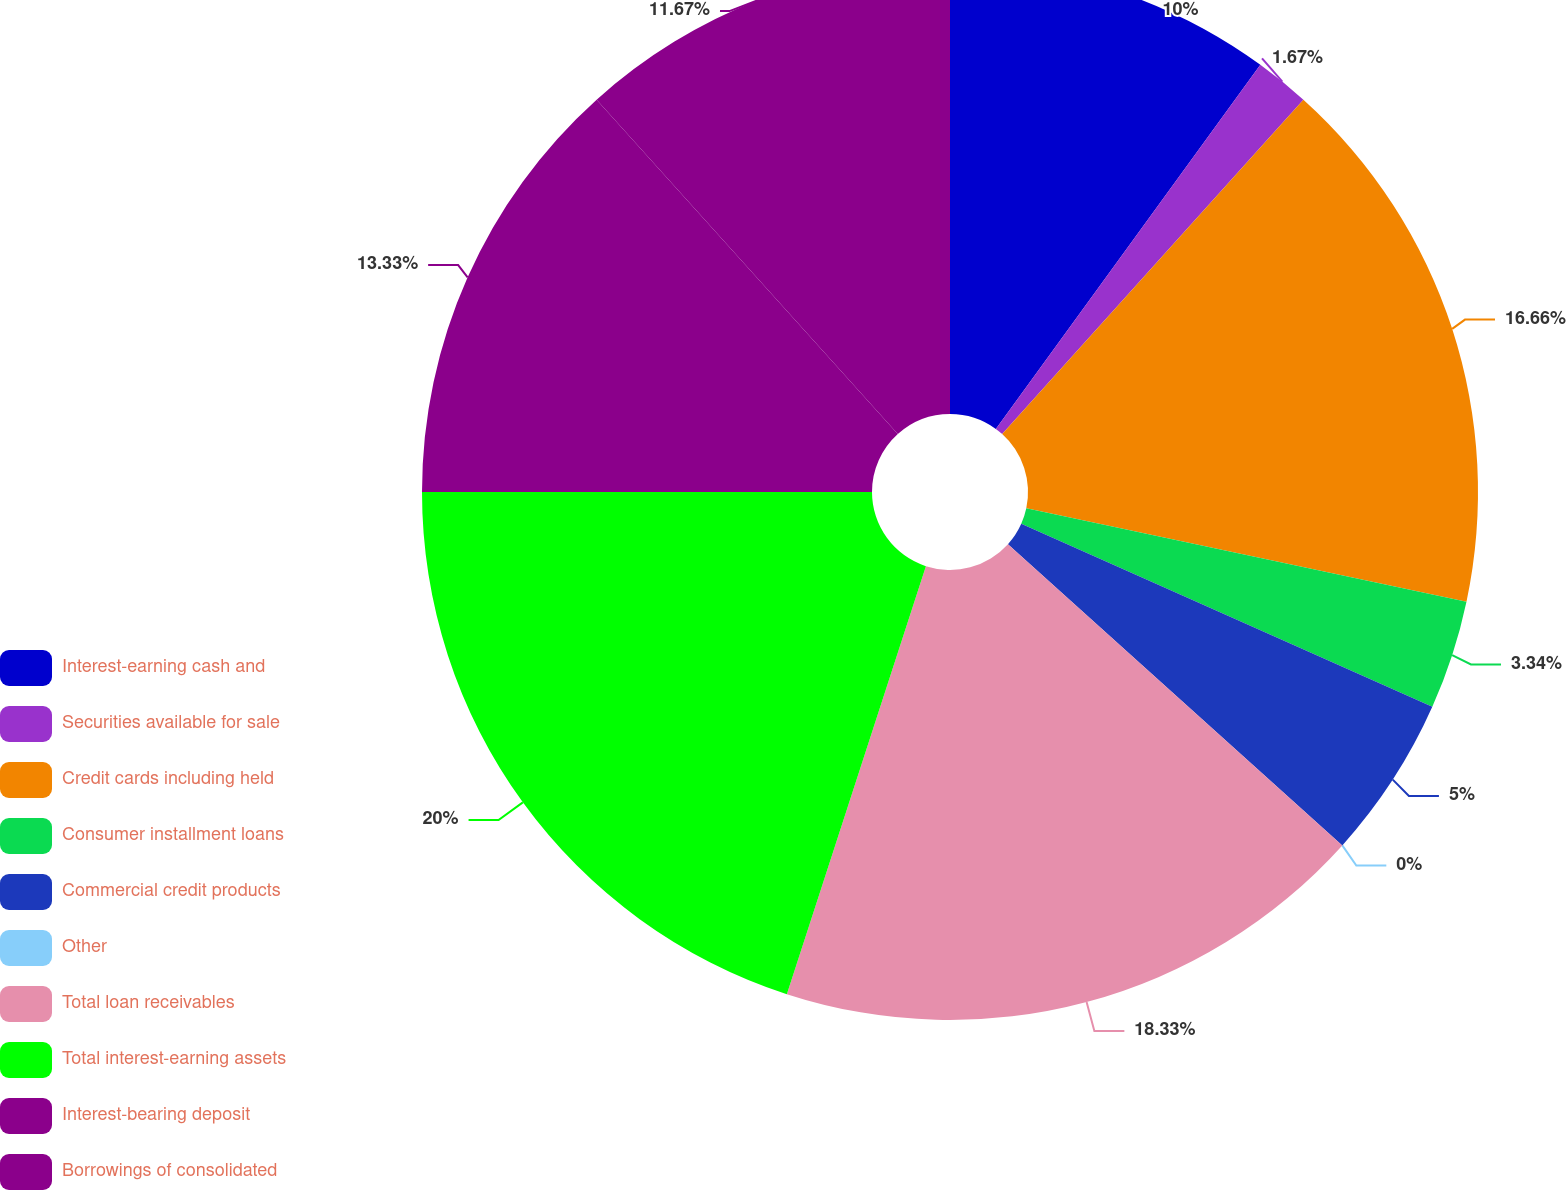<chart> <loc_0><loc_0><loc_500><loc_500><pie_chart><fcel>Interest-earning cash and<fcel>Securities available for sale<fcel>Credit cards including held<fcel>Consumer installment loans<fcel>Commercial credit products<fcel>Other<fcel>Total loan receivables<fcel>Total interest-earning assets<fcel>Interest-bearing deposit<fcel>Borrowings of consolidated<nl><fcel>10.0%<fcel>1.67%<fcel>16.66%<fcel>3.34%<fcel>5.0%<fcel>0.0%<fcel>18.33%<fcel>20.0%<fcel>13.33%<fcel>11.67%<nl></chart> 